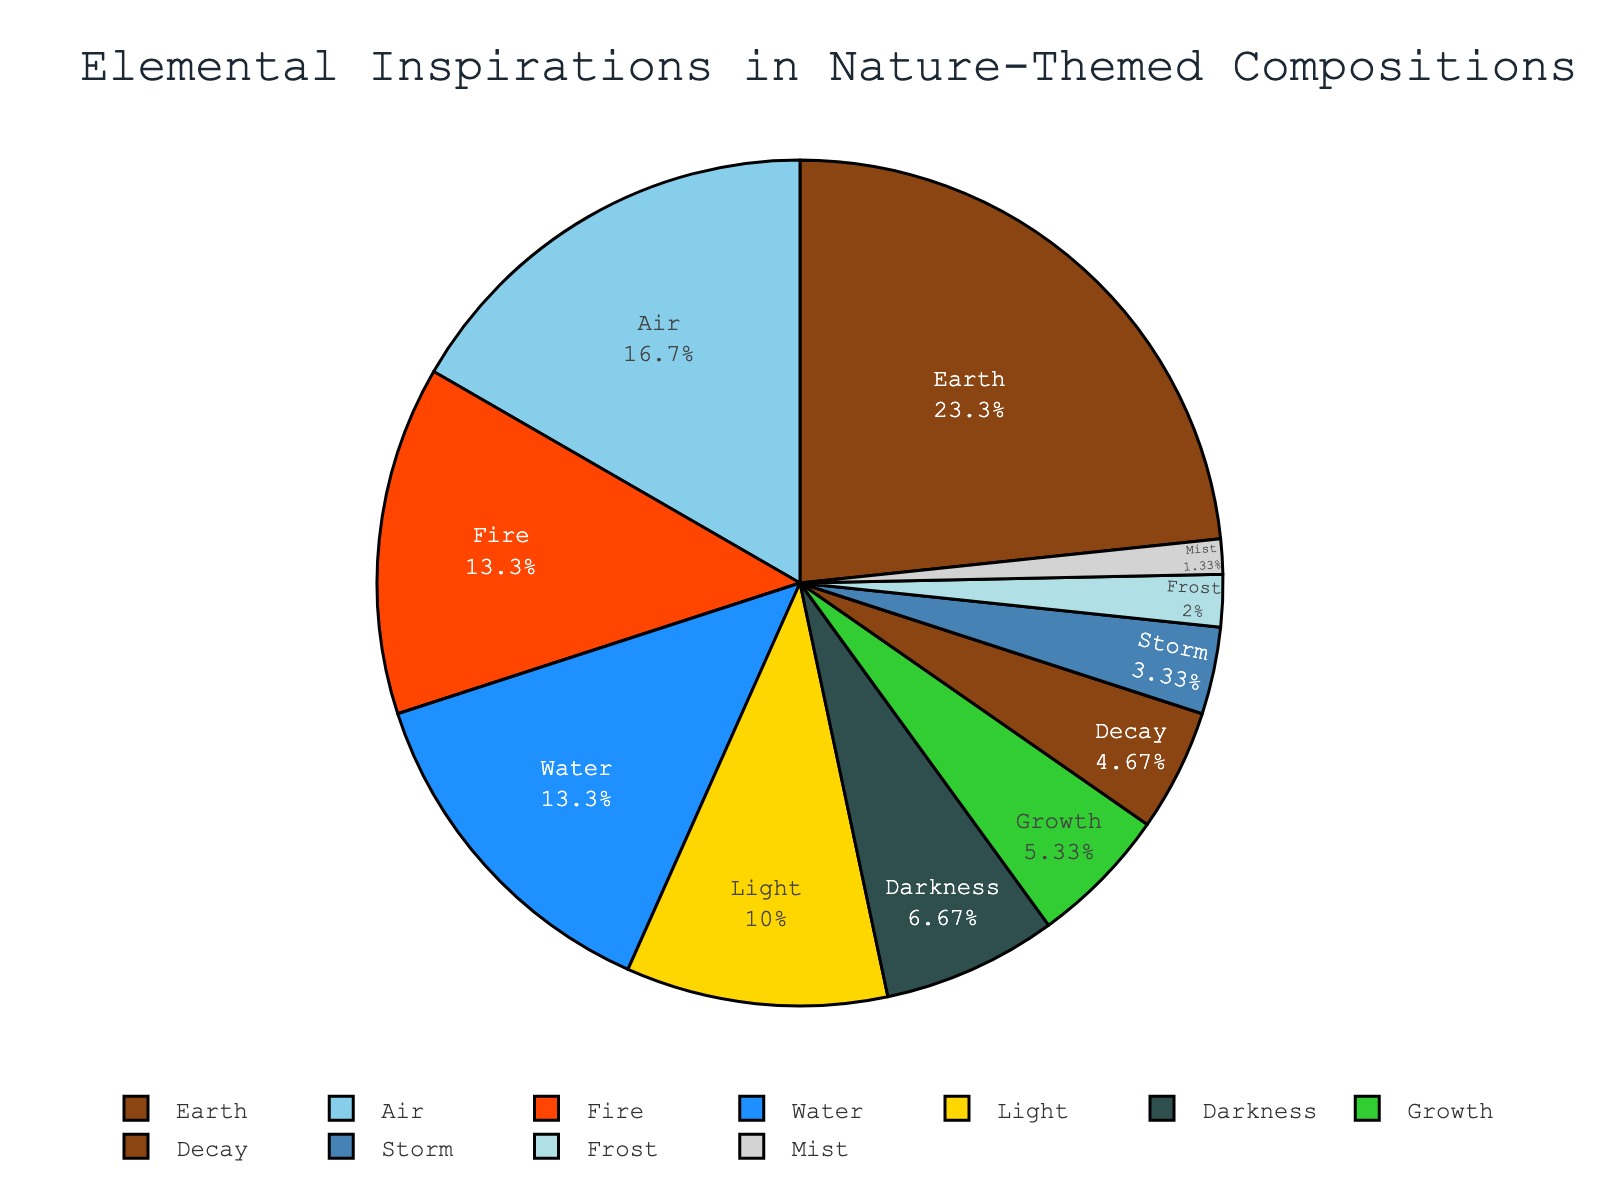What percentage of the compositions are inspired by water? If we look at the pie chart, we can see the percentage value for each element. The slice labeled "Water" shows a value of 20%.
Answer: 20% Which element has the highest percentage of inspiration? By observing the chart, we see the largest section of the pie chart belongs to the "Earth" element, with a value of 35%.
Answer: Earth How much more percentage does Earth have compared to Fire? Earth has a percentage of 35%, and Fire has a percentage of 20%. Subtracting Fire's percentage from Earth's percentage gives 35% - 20% = 15%.
Answer: 15% What is the combined percentage of inspirations from Earth and Air? Add the percentages of Earth and Air. Earth has 35% and Air has 25%, so the combined percentage is 35% + 25% = 60%.
Answer: 60% How does the inspiration from Light compare to Darkness? Light has a higher percentage of inspiration compared to Darkness. Light has 15%, while Darkness has 10%.
Answer: Light > Darkness In terms of percentage, how does the inspiration from Growth compare to Decay? Growth has an inspiration percentage of 8%, whereas Decay has a percentage of 7%. Growth is slightly higher than Decay.
Answer: Growth > Decay What is the combined percentage of the least three inspirations? The least three inspirations are Mist (2%), Frost (3%), and Storm (5%). Adding these gives 2% + 3% + 5% = 10%.
Answer: 10% Which elements have the same percentage of inspiration? Fire and Water both have 20% inspiration each, as shown in the pie chart.
Answer: Fire and Water What is the difference in percentages between the inspirations from Air and Light? Air has a percentage of 25%, and Light has a percentage of 15%. The difference is 25% - 15% = 10%.
Answer: 10% Which element has the smallest percentage of inspiration, and what is it? By looking at the pie chart, Mist has the smallest slice with a percentage of 2%.
Answer: Mist, 2% 